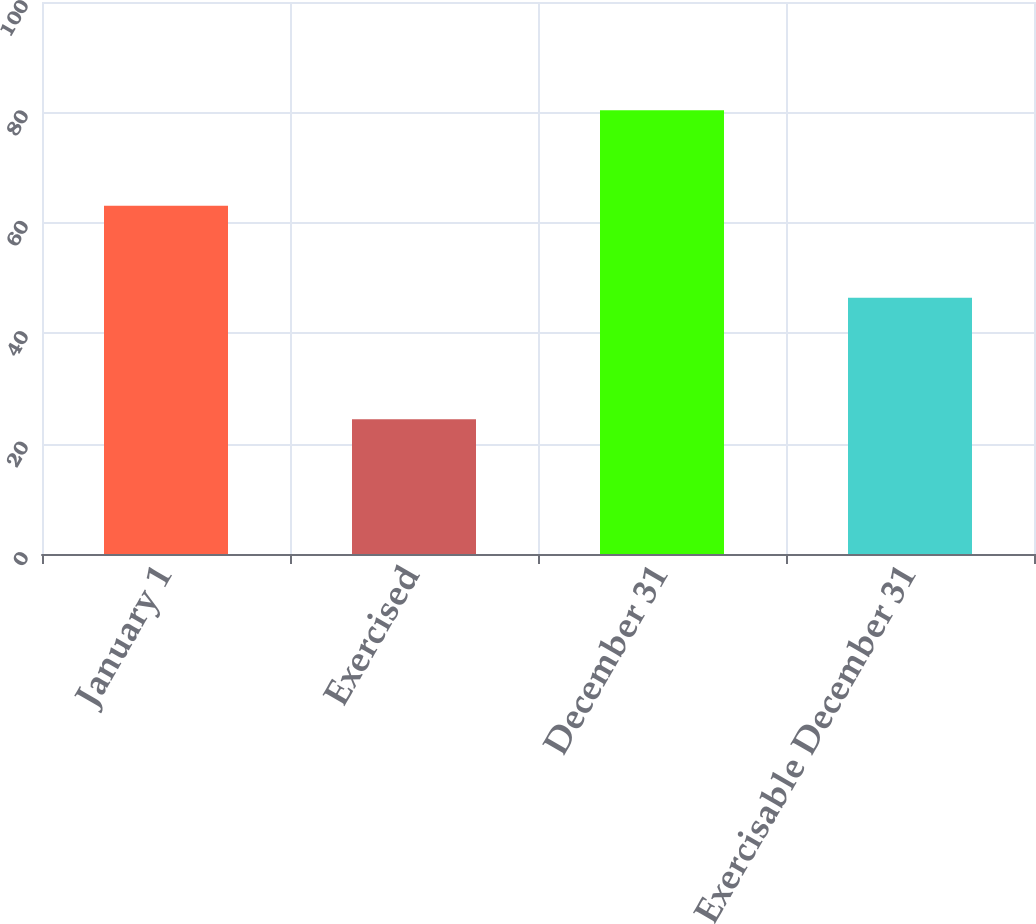Convert chart. <chart><loc_0><loc_0><loc_500><loc_500><bar_chart><fcel>January 1<fcel>Exercised<fcel>December 31<fcel>Exercisable December 31<nl><fcel>63.11<fcel>24.43<fcel>80.37<fcel>46.43<nl></chart> 